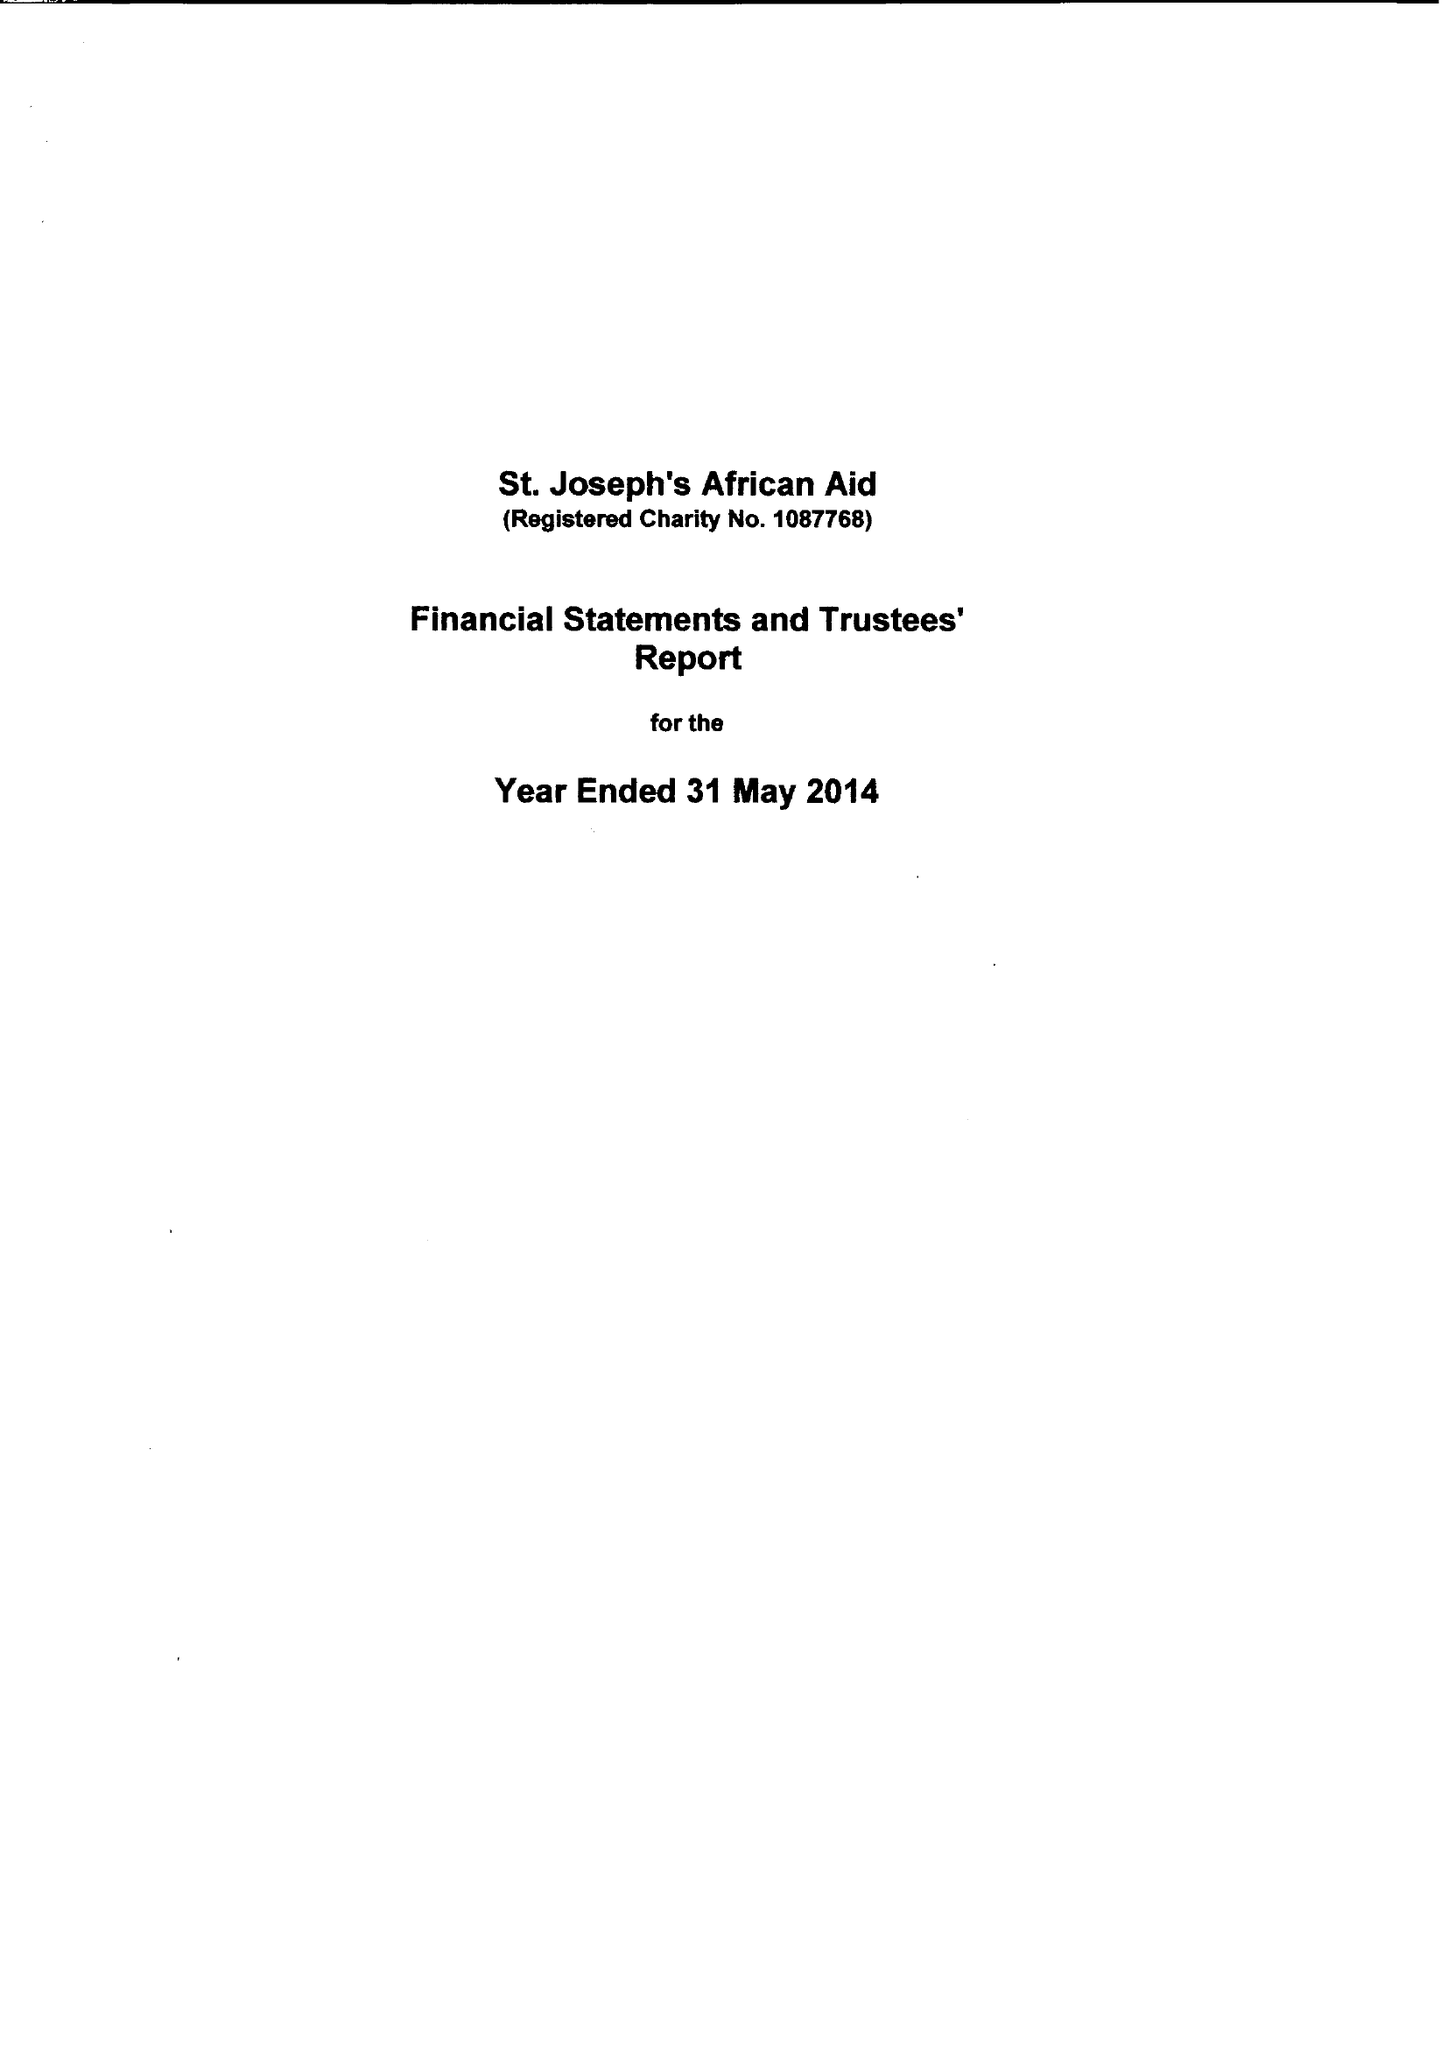What is the value for the income_annually_in_british_pounds?
Answer the question using a single word or phrase. 36244.00 